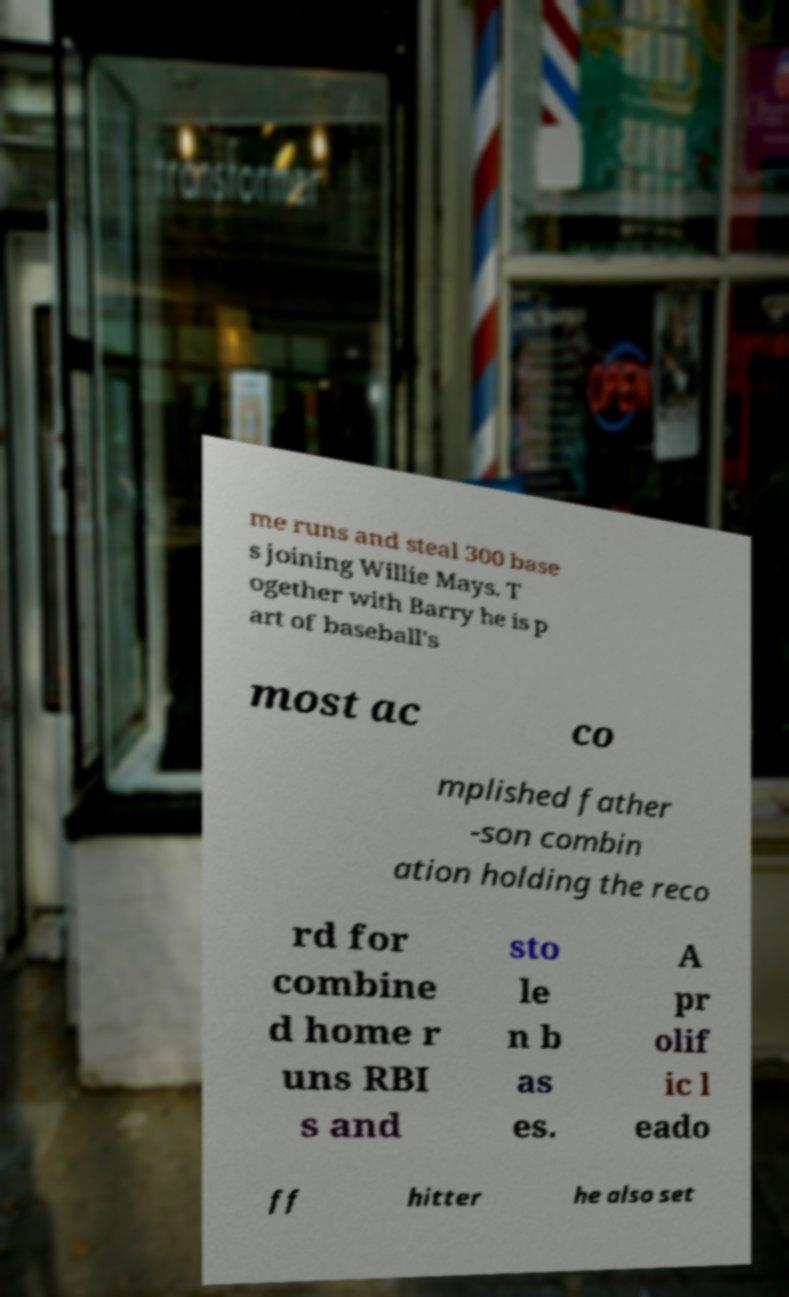Could you extract and type out the text from this image? me runs and steal 300 base s joining Willie Mays. T ogether with Barry he is p art of baseball's most ac co mplished father -son combin ation holding the reco rd for combine d home r uns RBI s and sto le n b as es. A pr olif ic l eado ff hitter he also set 